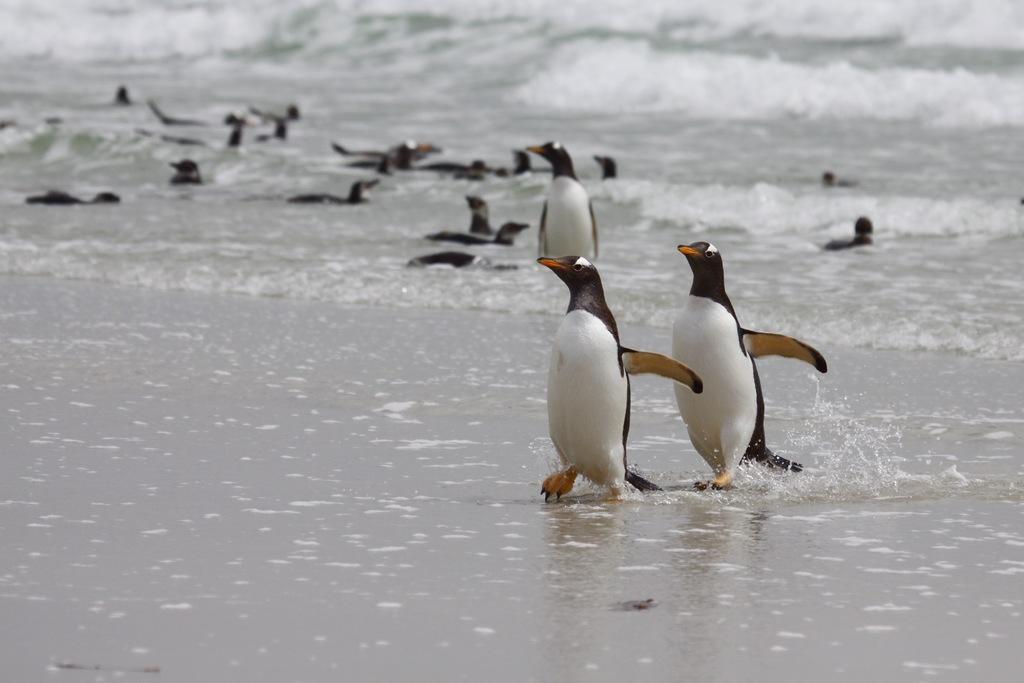In one or two sentences, can you explain what this image depicts? In this image we can see some penguins in the water and we can see the ocean. 